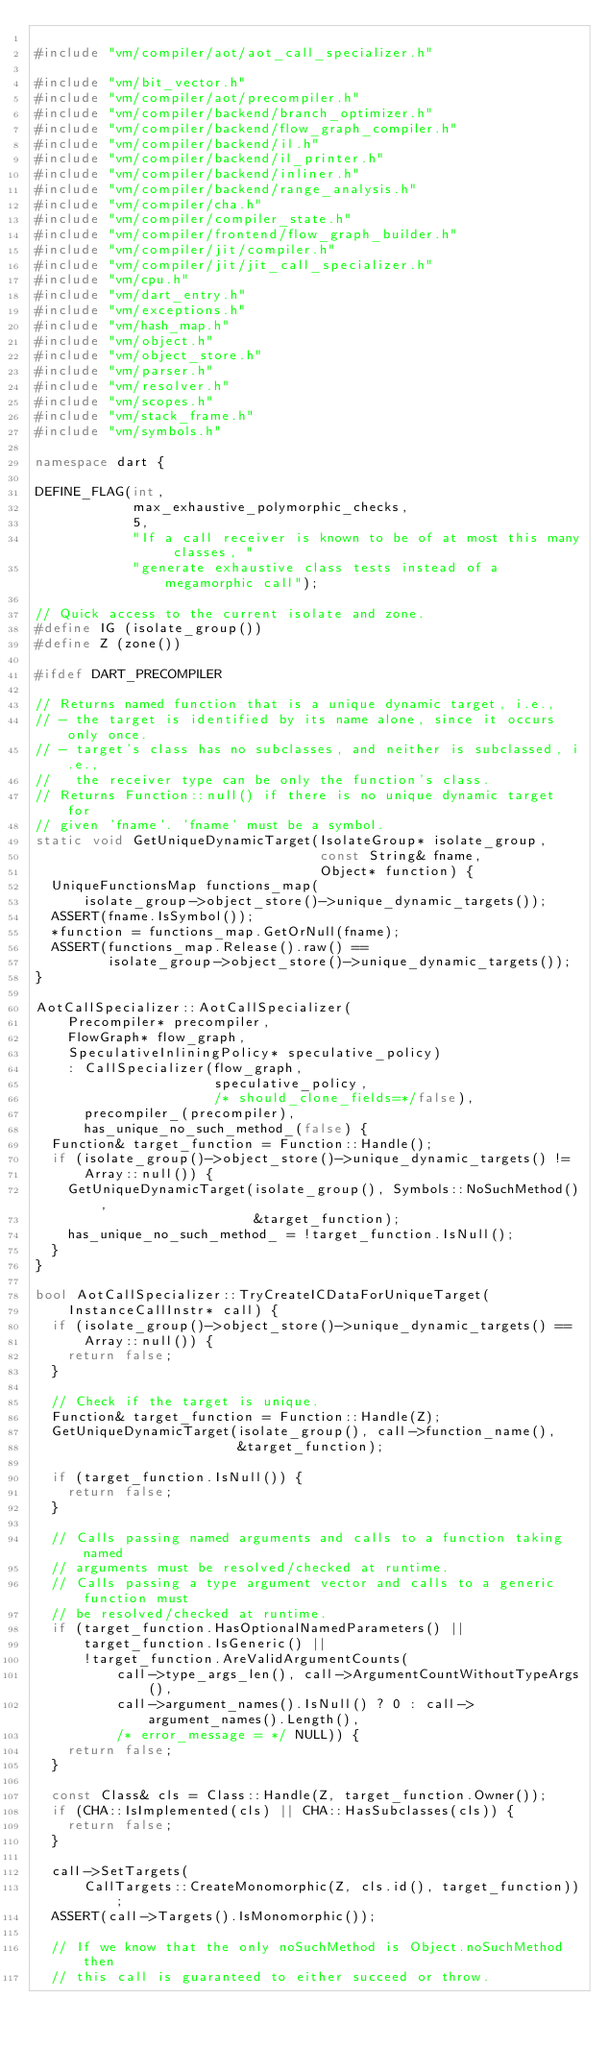Convert code to text. <code><loc_0><loc_0><loc_500><loc_500><_C++_>
#include "vm/compiler/aot/aot_call_specializer.h"

#include "vm/bit_vector.h"
#include "vm/compiler/aot/precompiler.h"
#include "vm/compiler/backend/branch_optimizer.h"
#include "vm/compiler/backend/flow_graph_compiler.h"
#include "vm/compiler/backend/il.h"
#include "vm/compiler/backend/il_printer.h"
#include "vm/compiler/backend/inliner.h"
#include "vm/compiler/backend/range_analysis.h"
#include "vm/compiler/cha.h"
#include "vm/compiler/compiler_state.h"
#include "vm/compiler/frontend/flow_graph_builder.h"
#include "vm/compiler/jit/compiler.h"
#include "vm/compiler/jit/jit_call_specializer.h"
#include "vm/cpu.h"
#include "vm/dart_entry.h"
#include "vm/exceptions.h"
#include "vm/hash_map.h"
#include "vm/object.h"
#include "vm/object_store.h"
#include "vm/parser.h"
#include "vm/resolver.h"
#include "vm/scopes.h"
#include "vm/stack_frame.h"
#include "vm/symbols.h"

namespace dart {

DEFINE_FLAG(int,
            max_exhaustive_polymorphic_checks,
            5,
            "If a call receiver is known to be of at most this many classes, "
            "generate exhaustive class tests instead of a megamorphic call");

// Quick access to the current isolate and zone.
#define IG (isolate_group())
#define Z (zone())

#ifdef DART_PRECOMPILER

// Returns named function that is a unique dynamic target, i.e.,
// - the target is identified by its name alone, since it occurs only once.
// - target's class has no subclasses, and neither is subclassed, i.e.,
//   the receiver type can be only the function's class.
// Returns Function::null() if there is no unique dynamic target for
// given 'fname'. 'fname' must be a symbol.
static void GetUniqueDynamicTarget(IsolateGroup* isolate_group,
                                   const String& fname,
                                   Object* function) {
  UniqueFunctionsMap functions_map(
      isolate_group->object_store()->unique_dynamic_targets());
  ASSERT(fname.IsSymbol());
  *function = functions_map.GetOrNull(fname);
  ASSERT(functions_map.Release().raw() ==
         isolate_group->object_store()->unique_dynamic_targets());
}

AotCallSpecializer::AotCallSpecializer(
    Precompiler* precompiler,
    FlowGraph* flow_graph,
    SpeculativeInliningPolicy* speculative_policy)
    : CallSpecializer(flow_graph,
                      speculative_policy,
                      /* should_clone_fields=*/false),
      precompiler_(precompiler),
      has_unique_no_such_method_(false) {
  Function& target_function = Function::Handle();
  if (isolate_group()->object_store()->unique_dynamic_targets() !=
      Array::null()) {
    GetUniqueDynamicTarget(isolate_group(), Symbols::NoSuchMethod(),
                           &target_function);
    has_unique_no_such_method_ = !target_function.IsNull();
  }
}

bool AotCallSpecializer::TryCreateICDataForUniqueTarget(
    InstanceCallInstr* call) {
  if (isolate_group()->object_store()->unique_dynamic_targets() ==
      Array::null()) {
    return false;
  }

  // Check if the target is unique.
  Function& target_function = Function::Handle(Z);
  GetUniqueDynamicTarget(isolate_group(), call->function_name(),
                         &target_function);

  if (target_function.IsNull()) {
    return false;
  }

  // Calls passing named arguments and calls to a function taking named
  // arguments must be resolved/checked at runtime.
  // Calls passing a type argument vector and calls to a generic function must
  // be resolved/checked at runtime.
  if (target_function.HasOptionalNamedParameters() ||
      target_function.IsGeneric() ||
      !target_function.AreValidArgumentCounts(
          call->type_args_len(), call->ArgumentCountWithoutTypeArgs(),
          call->argument_names().IsNull() ? 0 : call->argument_names().Length(),
          /* error_message = */ NULL)) {
    return false;
  }

  const Class& cls = Class::Handle(Z, target_function.Owner());
  if (CHA::IsImplemented(cls) || CHA::HasSubclasses(cls)) {
    return false;
  }

  call->SetTargets(
      CallTargets::CreateMonomorphic(Z, cls.id(), target_function));
  ASSERT(call->Targets().IsMonomorphic());

  // If we know that the only noSuchMethod is Object.noSuchMethod then
  // this call is guaranteed to either succeed or throw.</code> 